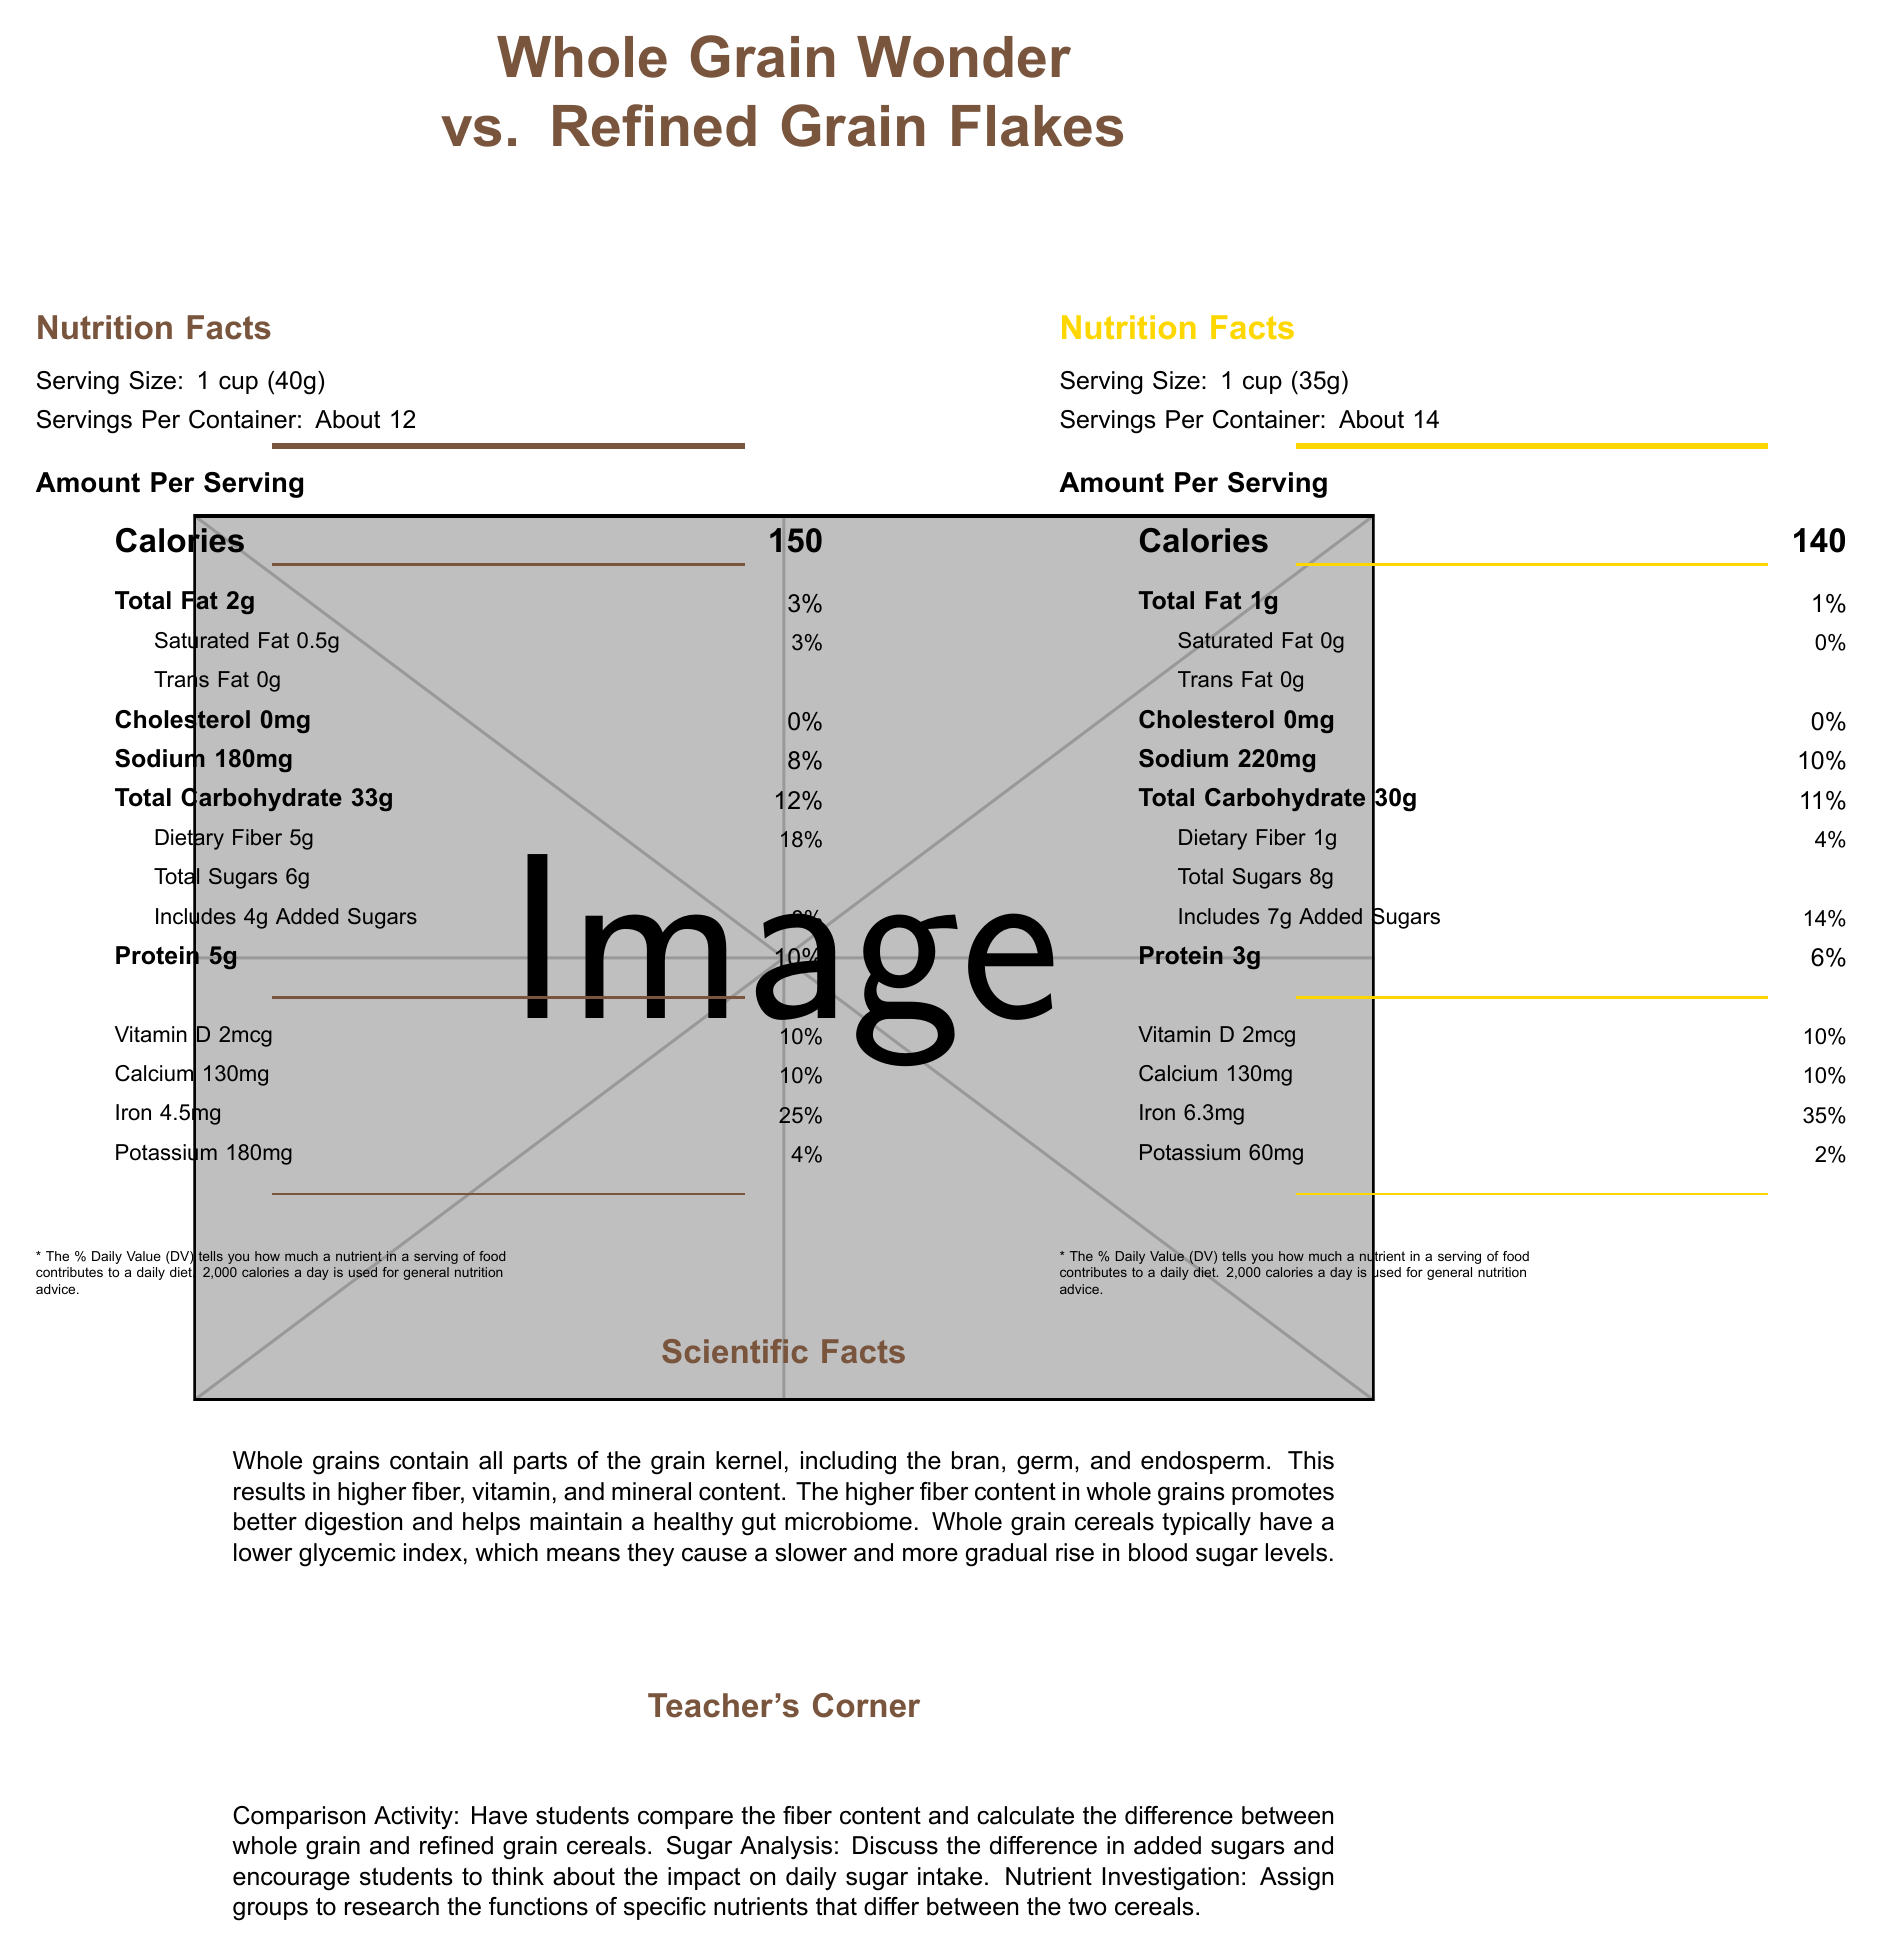what is the serving size for Whole Grain Wonder? According to the document, the serving size for Whole Grain Wonder is listed as 1 cup (40g).
Answer: 1 cup (40g) what is the difference in dietary fiber content between Whole Grain Wonder and Refined Grain Flakes? Whole Grain Wonder has 5 grams of dietary fiber, while Refined Grain Flakes contains only 1 gram. The difference is 5g - 1g = 4 grams.
Answer: 4 grams which cereal contains more sodium? A. Whole Grain Wonder B. Refined Grain Flakes Refined Grain Flakes contains 220 milligrams of sodium, while Whole Grain Wonder contains 180 milligrams. Therefore, Refined Grain Flakes has more sodium.
Answer: B how many servings per container are there for Refined Grain Flakes? The document lists about 14 servings per container for Refined Grain Flakes.
Answer: About 14 does Whole Grain Wonder contain any trans fat? Whole Grain Wonder contains 0 grams of trans fat, as indicated in the document.
Answer: No describe the main nutritional differences between Whole Grain Wonder and Refined Grain Flakes. Whole Grain Wonder has 5 grams of fiber compared to 1 gram in Refined Grain Flakes and slightly more calories (150 vs. 140). Whole Grain Wonder also contains less sodium (180mg vs. 220mg) and more dietary fiber. In terms of micronutrients, Refined Grain Flakes has more iron and higher added sugar content.
Answer: Whole Grain Wonder generally has higher fiber, slightly more calories, and less sodium. Refined Grain Flakes has more iron and added sugars. which cereal is higher in protein content, Whole Grain Wonder or Refined Grain Flakes? Whole Grain Wonder has 5 grams of protein, while Refined Grain Flakes only has 3 grams. Thus, Whole Grain Wonder is higher in protein content.
Answer: Whole Grain Wonder what is the glycemic index of Whole Grain Wonder? The document does not provide the exact glycemic index values for Whole Grain Wonder or Refined Grain Flakes. It only mentions that whole grain cereals typically have a lower glycemic index.
Answer: Cannot be determined how much vitamin D is in a serving of each cereal? A. 1mcg B. 2mcg C. 3mcg D. 4mcg Both Whole Grain Wonder and Refined Grain Flakes contain 2mcg of vitamin D per serving.
Answer: B are both cereals cholesterol free? Both Whole Grain Wonder and Refined Grain Flakes contain 0 milligrams of cholesterol.
Answer: Yes what are the primary ingredients in Refined Grain Flakes? The document lists these ingredients for Refined Grain Flakes.
Answer: Rice, wheat flour, sugar, corn syrup, salt, malt flavoring, BHT added to preserve freshness. what is the added sugars percentage of daily value for Whole Grain Wonder? Whole Grain Wonder includes 4 grams of added sugars, which is 8% of the daily value as indicated in the document.
Answer: 8% 